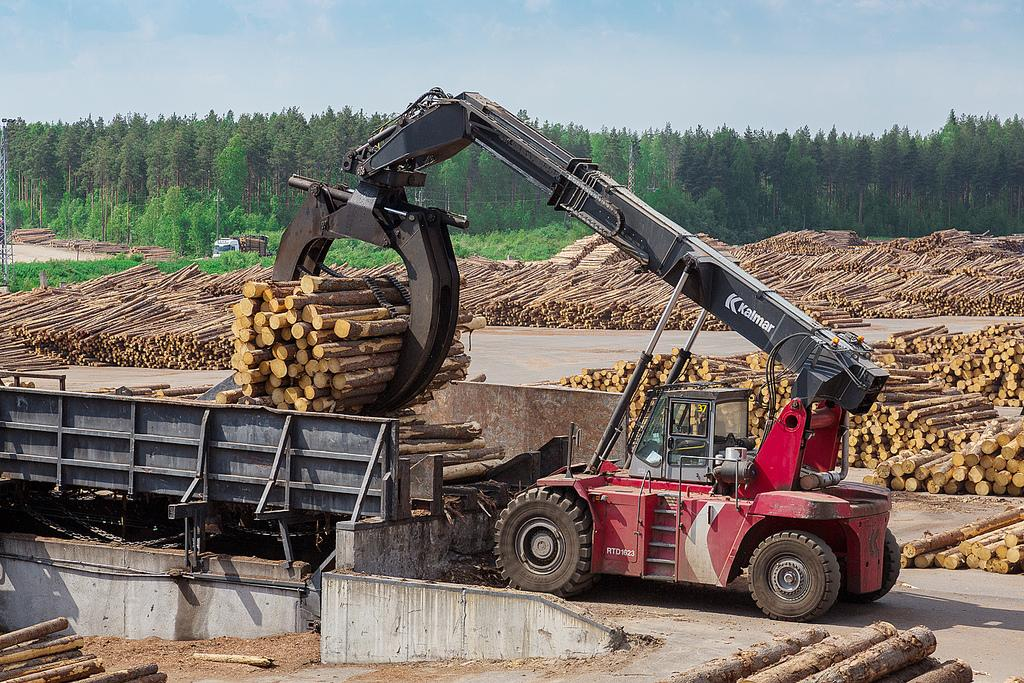What is being transported by the vehicles in the image? The vehicles in the image are carrying wooden logs. What type of objects can be seen in the image besides the vehicles? There are trees visible in the image. What is visible in the background of the image? The sky is visible in the background of the image. Who is wearing a crown in the image? There is no person wearing a crown in the image. What force is being applied to the wooden logs in the image? The image does not show any force being applied to the wooden logs; they are simply being transported by the vehicles. 